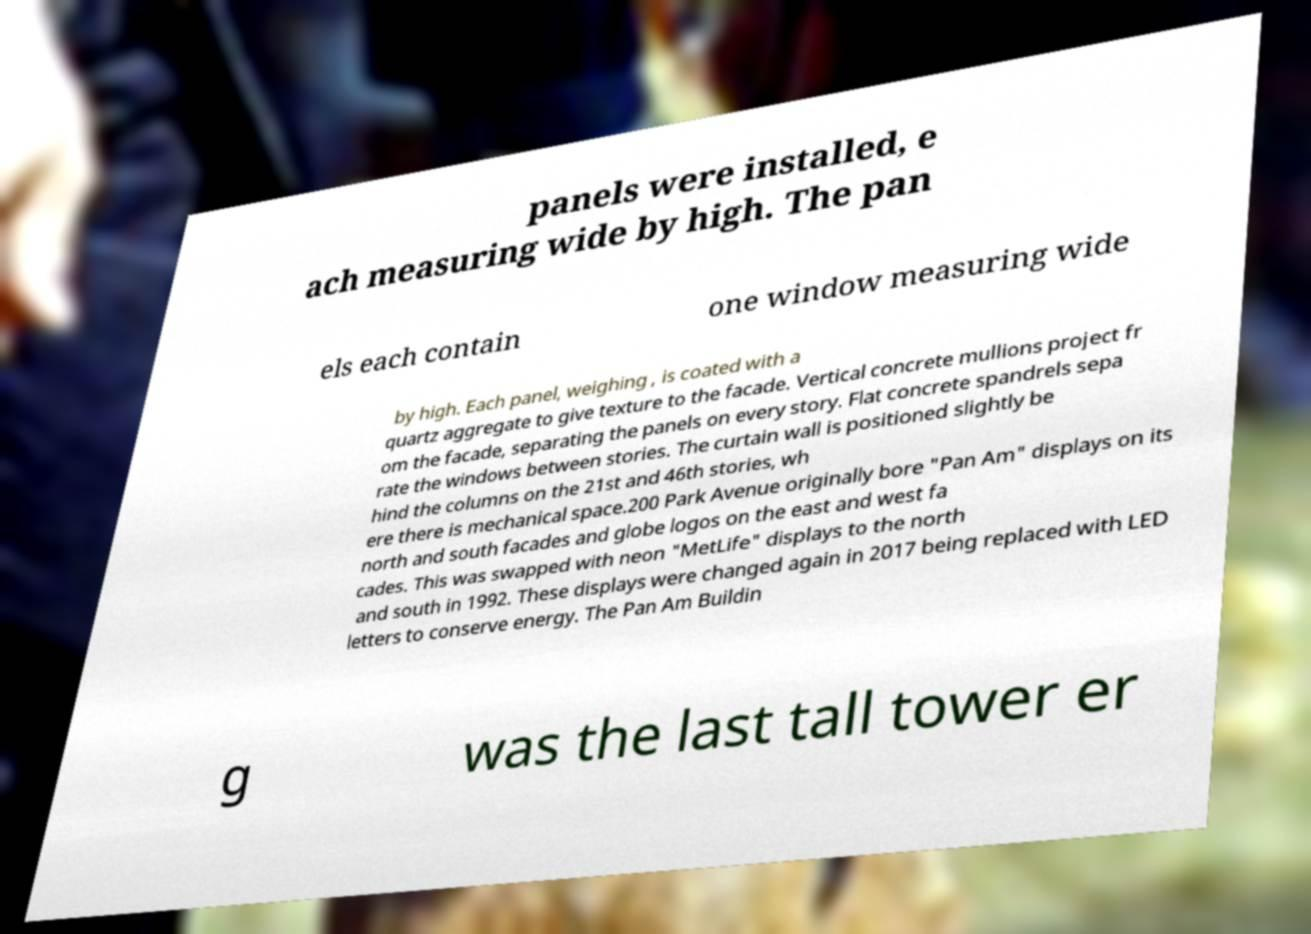What messages or text are displayed in this image? I need them in a readable, typed format. panels were installed, e ach measuring wide by high. The pan els each contain one window measuring wide by high. Each panel, weighing , is coated with a quartz aggregate to give texture to the facade. Vertical concrete mullions project fr om the facade, separating the panels on every story. Flat concrete spandrels sepa rate the windows between stories. The curtain wall is positioned slightly be hind the columns on the 21st and 46th stories, wh ere there is mechanical space.200 Park Avenue originally bore "Pan Am" displays on its north and south facades and globe logos on the east and west fa cades. This was swapped with neon "MetLife" displays to the north and south in 1992. These displays were changed again in 2017 being replaced with LED letters to conserve energy. The Pan Am Buildin g was the last tall tower er 